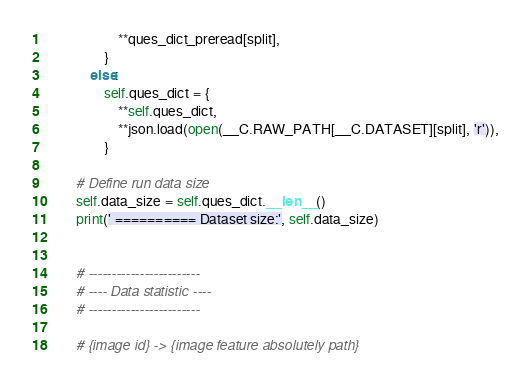<code> <loc_0><loc_0><loc_500><loc_500><_Python_>                    **ques_dict_preread[split],
                }
            else:
                self.ques_dict = {
                    **self.ques_dict,
                    **json.load(open(__C.RAW_PATH[__C.DATASET][split], 'r')),
                }

        # Define run data size
        self.data_size = self.ques_dict.__len__()
        print(' ========== Dataset size:', self.data_size)


        # ------------------------
        # ---- Data statistic ----
        # ------------------------

        # {image id} -> {image feature absolutely path}</code> 